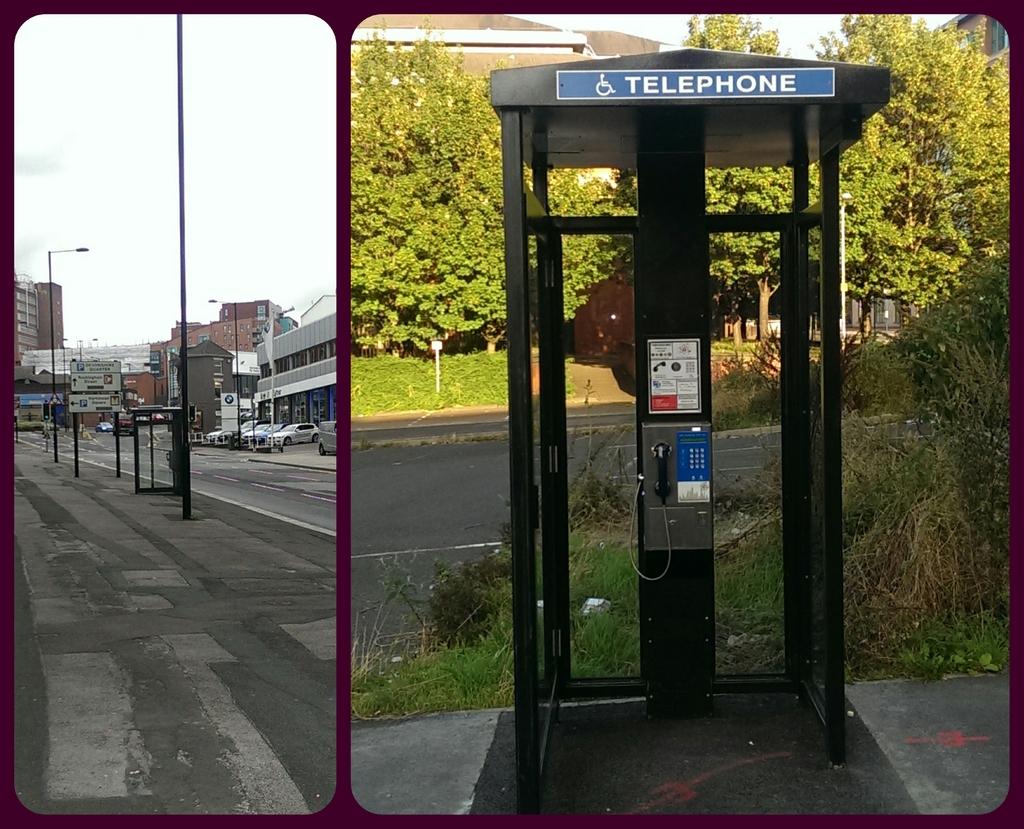Is this a telephone booth?
Your answer should be very brief. Yes. 